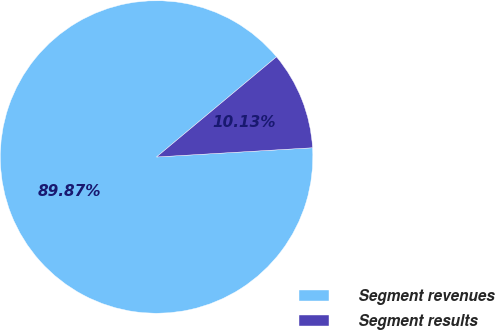Convert chart. <chart><loc_0><loc_0><loc_500><loc_500><pie_chart><fcel>Segment revenues<fcel>Segment results<nl><fcel>89.87%<fcel>10.13%<nl></chart> 